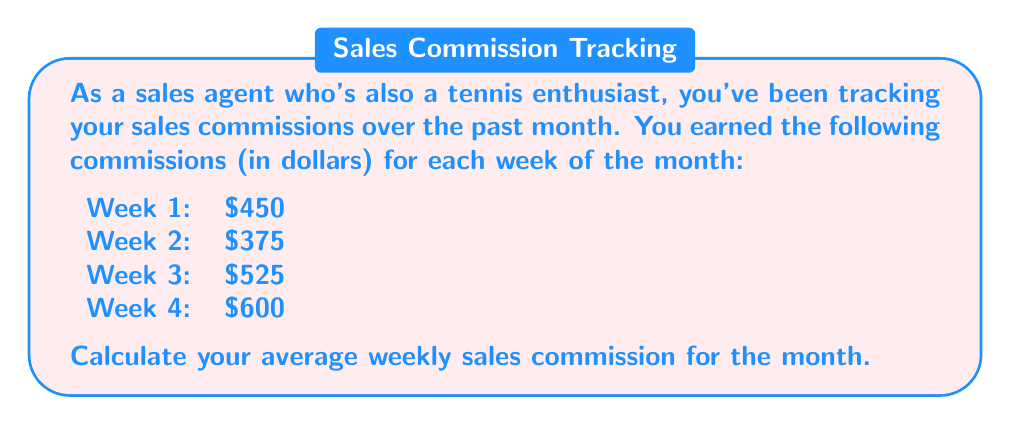Provide a solution to this math problem. To calculate the average weekly sales commission, we need to follow these steps:

1. Add up all the weekly commissions:
   $$ \text{Total commission} = 450 + 375 + 525 + 600 $$
   $$ \text{Total commission} = 1950 $$

2. Count the number of weeks:
   There are 4 weeks in this data set.

3. Use the formula for calculating the average:
   $$ \text{Average} = \frac{\text{Sum of all values}}{\text{Number of values}} $$

4. Plug in the values:
   $$ \text{Average weekly commission} = \frac{1950}{4} $$

5. Perform the division:
   $$ \text{Average weekly commission} = 487.50 $$

Therefore, your average weekly sales commission for the month is $487.50.
Answer: $487.50 